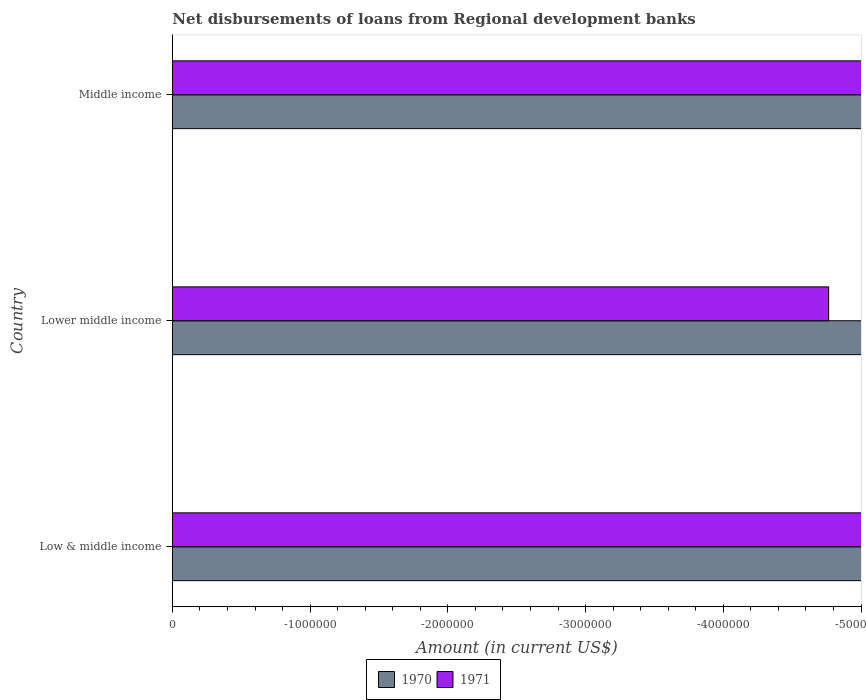In how many cases, is the number of bars for a given country not equal to the number of legend labels?
Your answer should be compact. 3. What is the amount of disbursements of loans from regional development banks in 1970 in Low & middle income?
Give a very brief answer. 0. Across all countries, what is the minimum amount of disbursements of loans from regional development banks in 1971?
Keep it short and to the point. 0. What is the difference between the amount of disbursements of loans from regional development banks in 1971 in Lower middle income and the amount of disbursements of loans from regional development banks in 1970 in Middle income?
Give a very brief answer. 0. How many bars are there?
Your answer should be compact. 0. How many countries are there in the graph?
Your answer should be compact. 3. What is the difference between two consecutive major ticks on the X-axis?
Make the answer very short. 1.00e+06. Are the values on the major ticks of X-axis written in scientific E-notation?
Provide a short and direct response. No. Where does the legend appear in the graph?
Ensure brevity in your answer.  Bottom center. How many legend labels are there?
Provide a succinct answer. 2. How are the legend labels stacked?
Ensure brevity in your answer.  Horizontal. What is the title of the graph?
Your answer should be very brief. Net disbursements of loans from Regional development banks. What is the label or title of the X-axis?
Provide a succinct answer. Amount (in current US$). What is the Amount (in current US$) of 1970 in Lower middle income?
Ensure brevity in your answer.  0. What is the Amount (in current US$) of 1971 in Lower middle income?
Your response must be concise. 0. What is the Amount (in current US$) in 1971 in Middle income?
Offer a very short reply. 0. What is the average Amount (in current US$) in 1970 per country?
Your response must be concise. 0. What is the average Amount (in current US$) in 1971 per country?
Provide a succinct answer. 0. 